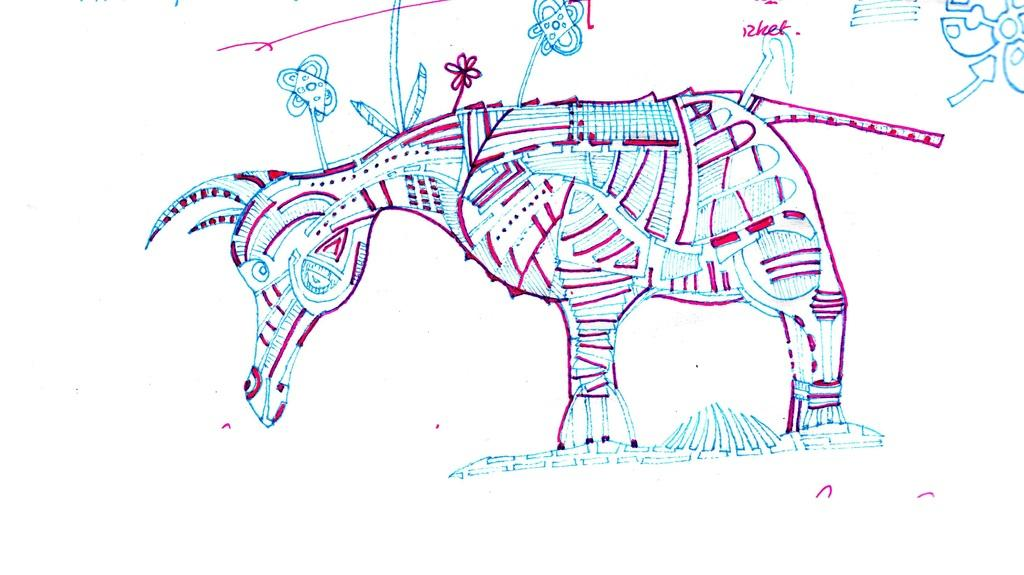What is depicted in the image? The image is a drawing of an animal. What type of receipt is visible in the image? There is no receipt present in the image; it is a drawing of an animal. What might be the artist's reaction to the surprise element in the image? There is no surprise element mentioned in the image, as it is simply a drawing of an animal. 